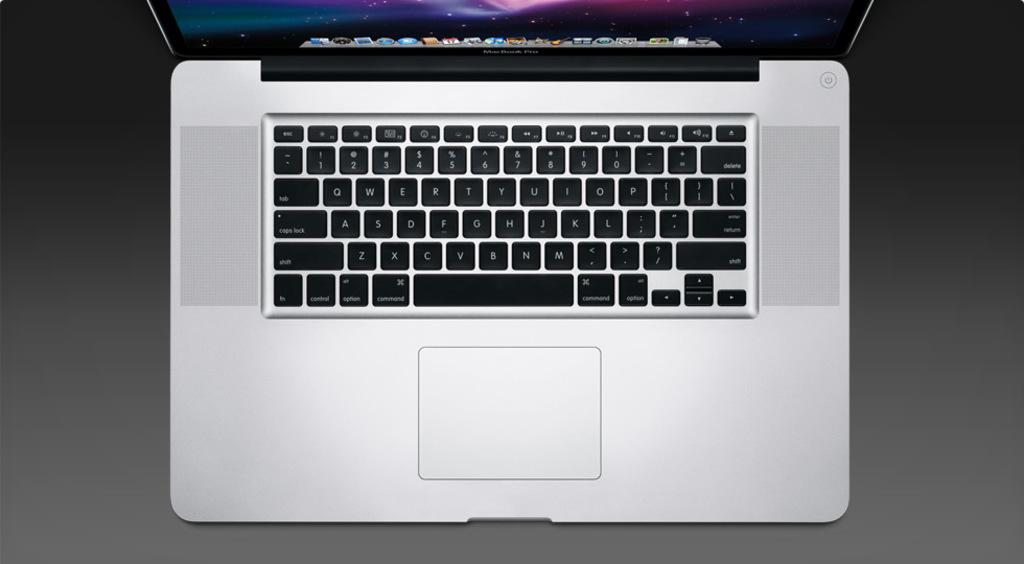<image>
Present a compact description of the photo's key features. A MacBook keyboard has a command key and an option key. 